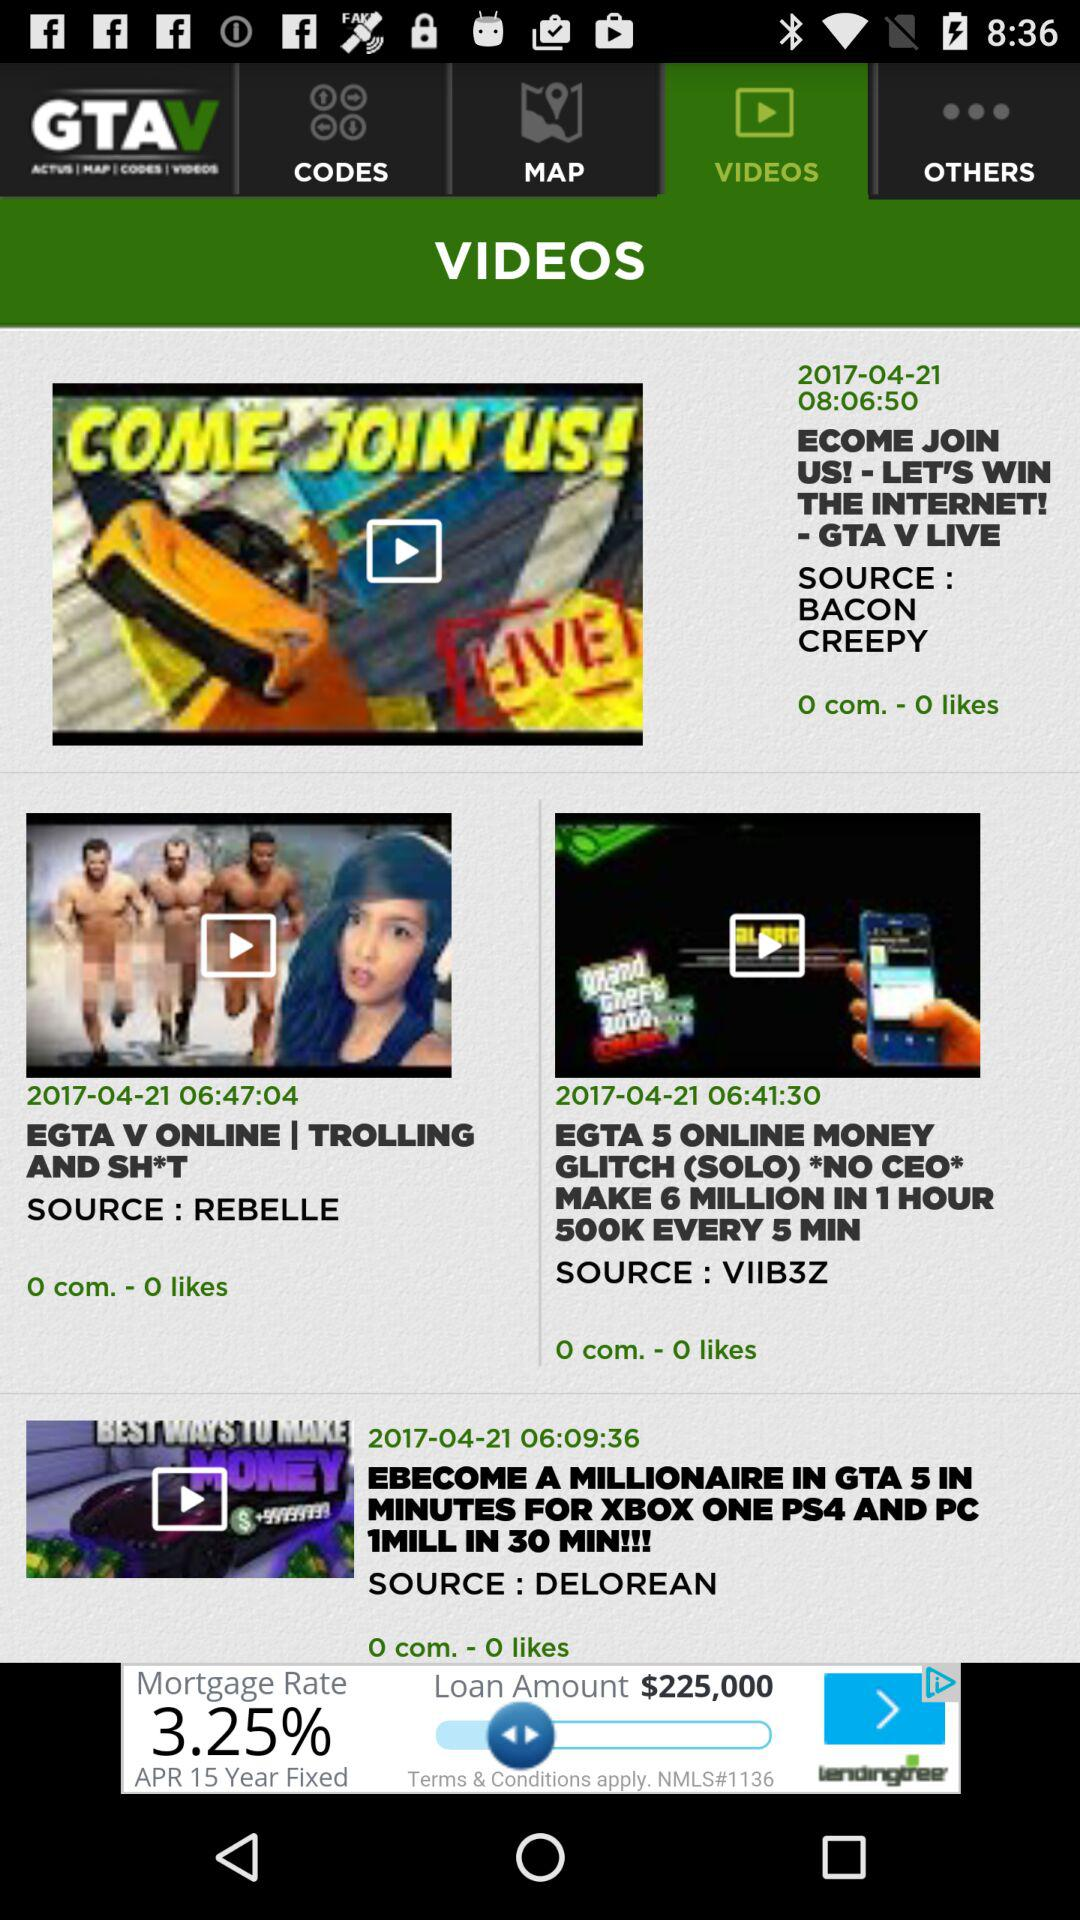What is the number of comments for the video "EGTA V ONLINE | TROLLING AND SH*T"? The number of comments is 0. 